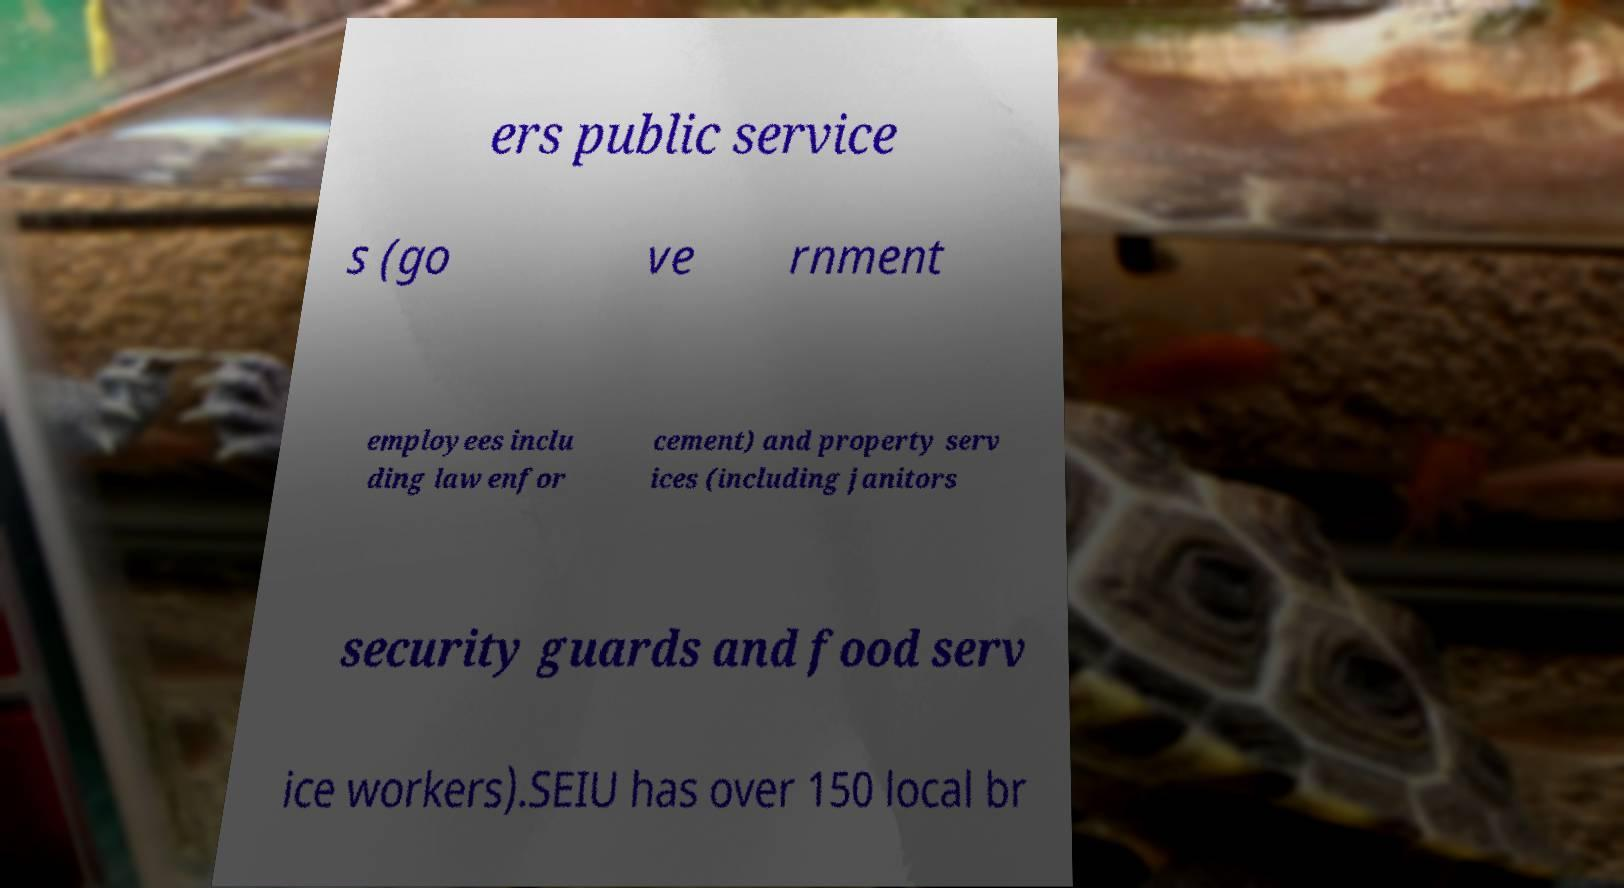Can you accurately transcribe the text from the provided image for me? ers public service s (go ve rnment employees inclu ding law enfor cement) and property serv ices (including janitors security guards and food serv ice workers).SEIU has over 150 local br 